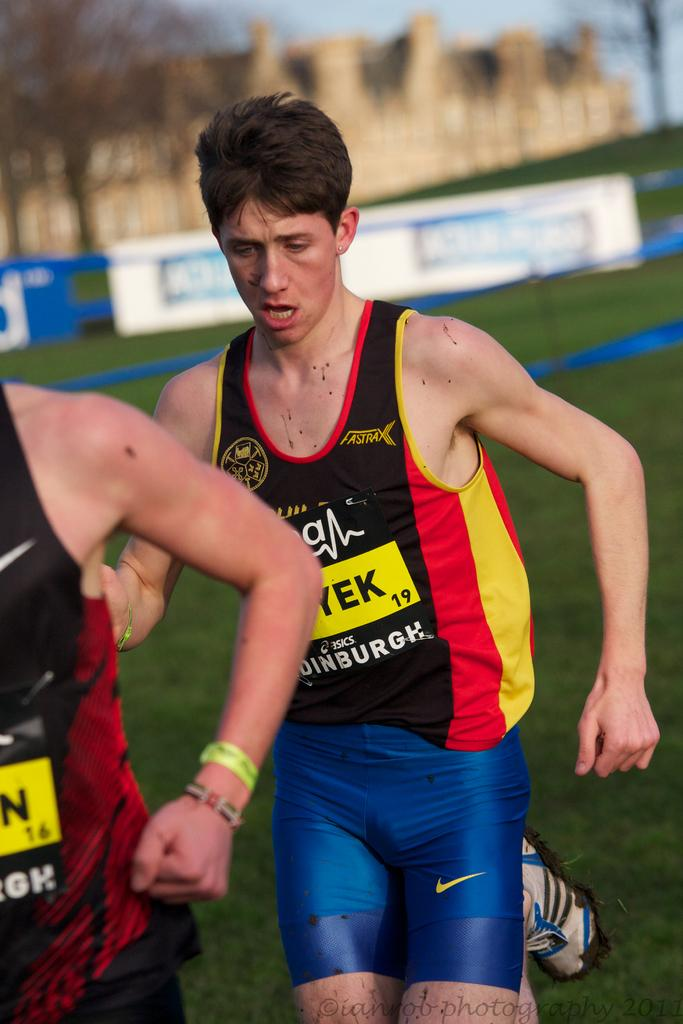Provide a one-sentence caption for the provided image. a boy running while wearing a jersey with FASTRAX label on it. 